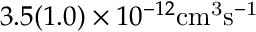<formula> <loc_0><loc_0><loc_500><loc_500>3 . 5 ( 1 . 0 ) \times 1 0 ^ { - 1 2 } { c m } ^ { 3 } \mathrm { { s } ^ { - 1 } }</formula> 